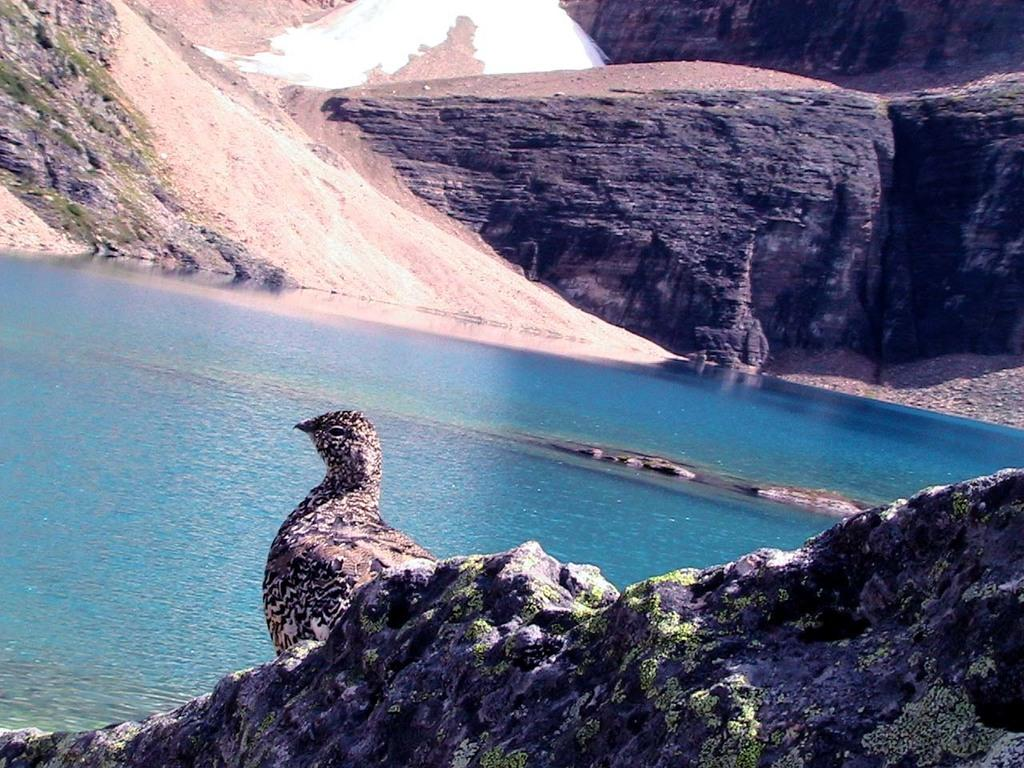What type of landscape can be seen in the image? There are hills in the image. What natural feature is present alongside the hills? There is a water body in the image. Are there any animals visible in the image? Yes, there is a bird in the image. What group of firemen can be seen in the image? There is no group of firemen present in the image. What type of ray is visible in the image? There is no ray visible in the image. 